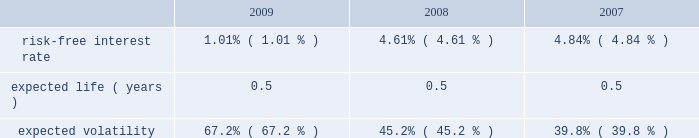Abiomed , inc .
And subsidiaries notes to consolidated financial statements 2014 ( continued ) note 12 .
Stock award plans and stock based compensation ( continued ) compensation expense recognized related to the company 2019s espp was approximately $ 0.1 million for each of the years ended march 31 , 2009 , 2008 and 2007 respectively .
The fair value of shares issued under the employee stock purchase plan was estimated on the commencement date of each offering period using the black-scholes option-pricing model with the following assumptions: .
Note 13 .
Capital stock in august 2008 , the company issued 2419932 shares of its common stock at a price of $ 17.3788 in a public offering , which resulted in net proceeds to the company of approximately $ 42.0 million , after deducting offering expenses .
In march 2007 , the company issued 5000000 shares of common stock in a public offering , and in april 2007 , an additional 80068 shares of common stock were issued in connection with the offering upon the partial exercise of the underwriters 2019 over-allotment option .
The company has authorized 1000000 shares of class b preferred stock , $ 0.01 par value , of which the board of directors can set the designation , rights and privileges .
No shares of class b preferred stock have been issued or are outstanding .
Note 14 .
Income taxes deferred tax assets and liabilities are recognized for the estimated future tax consequences attributable to tax benefit carryforwards and to differences between the financial statement amounts of assets and liabilities and their respective tax basis .
Deferred tax assets and liabilities are measured using enacted tax rates .
A valuation reserve is established if it is more likely than not that all or a portion of the deferred tax asset will not be realized .
The tax benefit associated with the stock option compensation deductions will be credited to equity when realized .
At march 31 , 2009 , the company had federal and state net operating loss carryforwards , or nols , of approximately $ 145.1 million and $ 97.1 million , respectively , which begin to expire in fiscal 2010 .
Additionally , at march 31 , 2009 , the company had federal and state research and development credit carryforwards of approximately $ 8.1 million and $ 4.2 million , respectively , which begin to expire in fiscal 2010 .
The company acquired impella , a german-based company , in may 2005 .
Impella had pre-acquisition net operating losses of approximately $ 18.2 million at the time of acquisition ( which is denominated in euros and is subject to foreign exchange remeasurement at each balance sheet date presented ) , and has since incurred net operating losses in each fiscal year since the acquisition .
During fiscal 2008 , the company determined that approximately $ 1.2 million of pre-acquisition operating losses could not be utilized .
The utilization of pre-acquisition net operating losses of impella in future periods is subject to certain statutory approvals and business requirements .
Due to uncertainties surrounding the company 2019s ability to generate future taxable income to realize these assets , a full valuation allowance has been established to offset the company 2019s net deferred tax assets and liabilities .
Additionally , the future utilization of the company 2019s nol and research and development credit carry forwards to offset future taxable income may be subject to a substantial annual limitation under section 382 of the internal revenue code due to ownership changes that have occurred previously or that could occur in the future .
Ownership changes , as defined in section 382 of the internal revenue code , can limit the amount of net operating loss carry forwards and research and development credit carry forwards that a company can use each year to offset future taxable income and taxes payable .
The company believes that all of its federal and state nol 2019s will be available for carryforward to future tax periods , subject to the statutory maximum carryforward limitation of any annual nol .
Any future potential limitation to all or a portion of the nol or research and development credit carry forwards , before they can be utilized , would reduce the company 2019s gross deferred tax assets .
The company will monitor subsequent ownership changes , which could impose limitations in the future. .
How many shares of common stock were issued during 2007? 
Computations: (5000000 + 80068)
Answer: 5080068.0. 